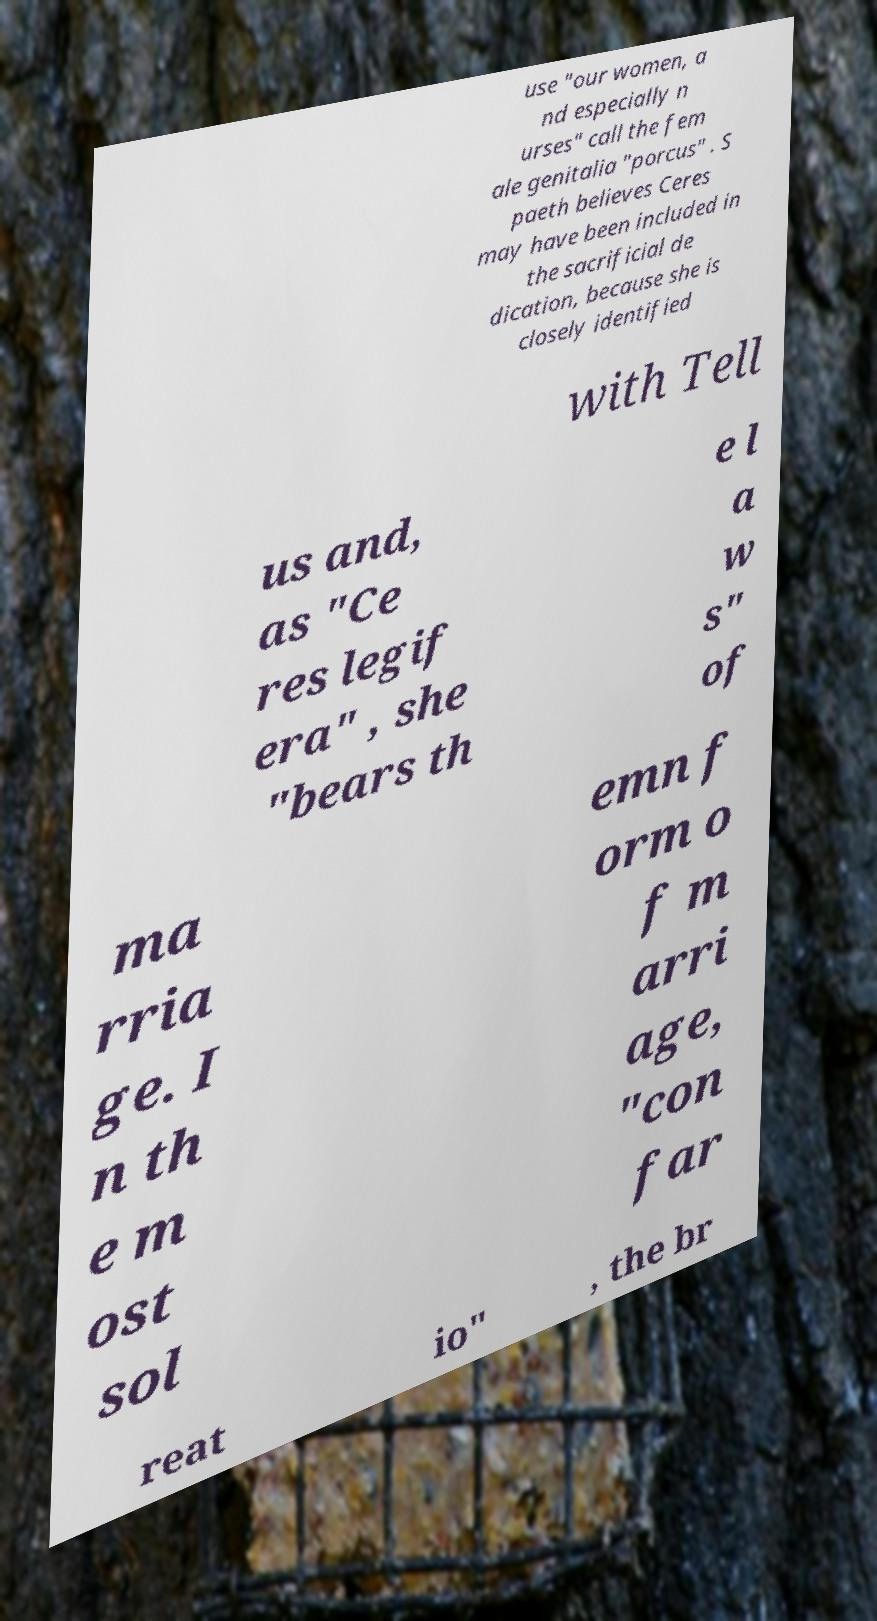Please read and relay the text visible in this image. What does it say? use "our women, a nd especially n urses" call the fem ale genitalia "porcus" . S paeth believes Ceres may have been included in the sacrificial de dication, because she is closely identified with Tell us and, as "Ce res legif era" , she "bears th e l a w s" of ma rria ge. I n th e m ost sol emn f orm o f m arri age, "con far reat io" , the br 